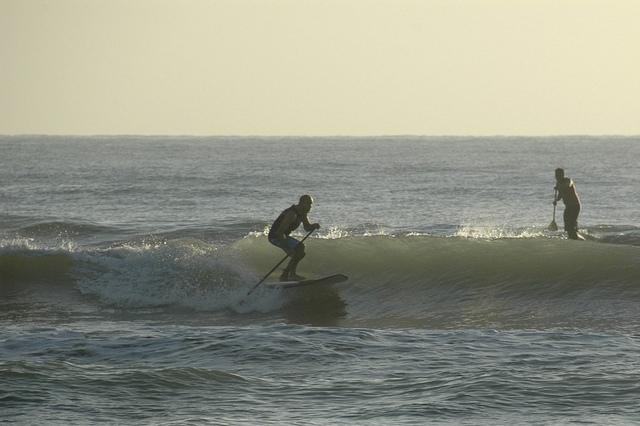What type of equipment are the people holding? oars 